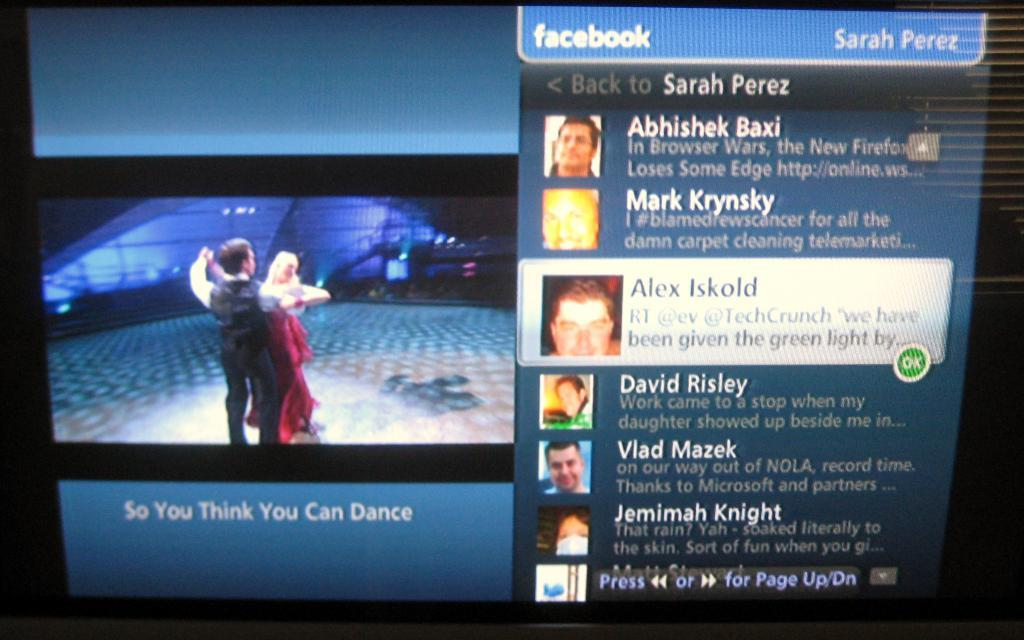<image>
Render a clear and concise summary of the photo. A facebook page is showing and it belongs to Sarah Perez. 